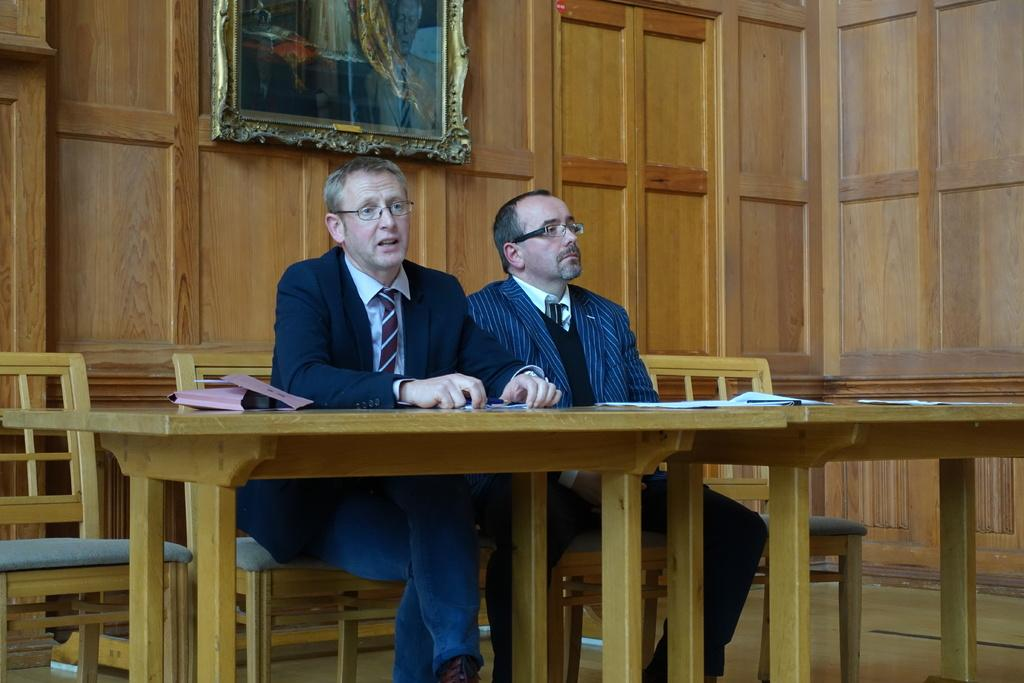How many people are sitting in the image? There are two persons sitting on chairs in the image. What is present on the table in the image? There is a paper and a pen on the table in the image. What is the person holding in the image? One person is holding a paper in the image. What can be seen in the background of the image? There is a frame and a wall visible in the background. What type of trade is being conducted in the image? There is no indication of any trade being conducted in the image. The image only shows two people sitting, a table with paper and pen, and a background with a frame and wall. 